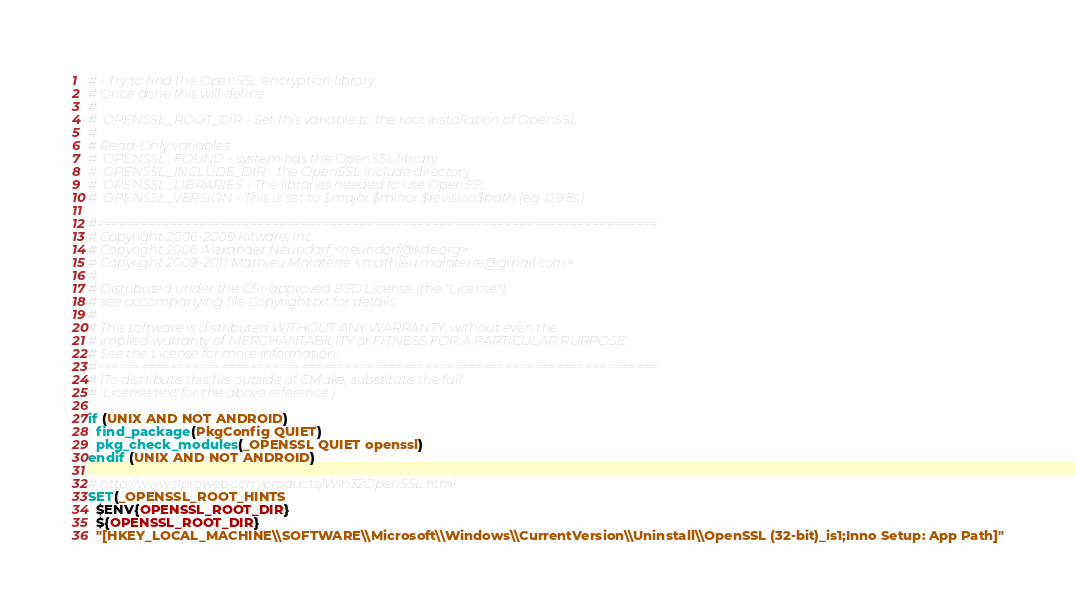<code> <loc_0><loc_0><loc_500><loc_500><_CMake_># - Try to find the OpenSSL encryption library
# Once done this will define
#
#  OPENSSL_ROOT_DIR - Set this variable to the root installation of OpenSSL
#
# Read-Only variables:
#  OPENSSL_FOUND - system has the OpenSSL library
#  OPENSSL_INCLUDE_DIR - the OpenSSL include directory
#  OPENSSL_LIBRARIES - The libraries needed to use OpenSSL
#  OPENSSL_VERSION - This is set to $major.$minor.$revision$path (eg. 0.9.8s)

#=============================================================================
# Copyright 2006-2009 Kitware, Inc.
# Copyright 2006 Alexander Neundorf <neundorf@kde.org>
# Copyright 2009-2011 Mathieu Malaterre <mathieu.malaterre@gmail.com>
#
# Distributed under the OSI-approved BSD License (the "License");
# see accompanying file Copyright.txt for details.
#
# This software is distributed WITHOUT ANY WARRANTY; without even the
# implied warranty of MERCHANTABILITY or FITNESS FOR A PARTICULAR PURPOSE.
# See the License for more information.
#=============================================================================
# (To distribute this file outside of CMake, substitute the full
#  License text for the above reference.)

if (UNIX AND NOT ANDROID)
  find_package(PkgConfig QUIET)
  pkg_check_modules(_OPENSSL QUIET openssl)
endif (UNIX AND NOT ANDROID)

# http://www.slproweb.com/products/Win32OpenSSL.html
SET(_OPENSSL_ROOT_HINTS
  $ENV{OPENSSL_ROOT_DIR}
  ${OPENSSL_ROOT_DIR}
  "[HKEY_LOCAL_MACHINE\\SOFTWARE\\Microsoft\\Windows\\CurrentVersion\\Uninstall\\OpenSSL (32-bit)_is1;Inno Setup: App Path]"</code> 